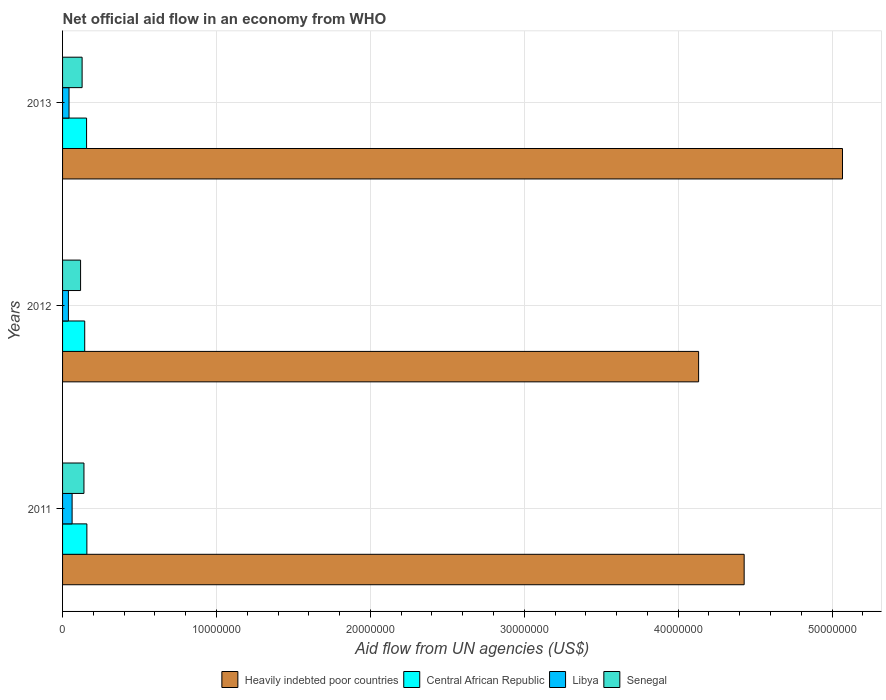How many different coloured bars are there?
Provide a succinct answer. 4. How many groups of bars are there?
Ensure brevity in your answer.  3. Are the number of bars per tick equal to the number of legend labels?
Give a very brief answer. Yes. How many bars are there on the 2nd tick from the top?
Give a very brief answer. 4. What is the net official aid flow in Libya in 2012?
Make the answer very short. 3.80e+05. Across all years, what is the maximum net official aid flow in Libya?
Your answer should be very brief. 6.20e+05. Across all years, what is the minimum net official aid flow in Senegal?
Keep it short and to the point. 1.17e+06. What is the total net official aid flow in Libya in the graph?
Provide a short and direct response. 1.42e+06. What is the difference between the net official aid flow in Heavily indebted poor countries in 2011 and that in 2013?
Provide a succinct answer. -6.39e+06. What is the average net official aid flow in Senegal per year?
Make the answer very short. 1.28e+06. In the year 2012, what is the difference between the net official aid flow in Libya and net official aid flow in Heavily indebted poor countries?
Your answer should be very brief. -4.10e+07. What is the ratio of the net official aid flow in Heavily indebted poor countries in 2012 to that in 2013?
Offer a terse response. 0.82. Is the difference between the net official aid flow in Libya in 2011 and 2012 greater than the difference between the net official aid flow in Heavily indebted poor countries in 2011 and 2012?
Your response must be concise. No. Is the sum of the net official aid flow in Senegal in 2011 and 2013 greater than the maximum net official aid flow in Central African Republic across all years?
Provide a short and direct response. Yes. What does the 2nd bar from the top in 2011 represents?
Offer a terse response. Libya. What does the 2nd bar from the bottom in 2011 represents?
Make the answer very short. Central African Republic. Is it the case that in every year, the sum of the net official aid flow in Heavily indebted poor countries and net official aid flow in Senegal is greater than the net official aid flow in Libya?
Your response must be concise. Yes. Are all the bars in the graph horizontal?
Give a very brief answer. Yes. Are the values on the major ticks of X-axis written in scientific E-notation?
Ensure brevity in your answer.  No. Does the graph contain grids?
Your answer should be very brief. Yes. Where does the legend appear in the graph?
Your answer should be very brief. Bottom center. How many legend labels are there?
Ensure brevity in your answer.  4. What is the title of the graph?
Your response must be concise. Net official aid flow in an economy from WHO. What is the label or title of the X-axis?
Your response must be concise. Aid flow from UN agencies (US$). What is the label or title of the Y-axis?
Provide a short and direct response. Years. What is the Aid flow from UN agencies (US$) in Heavily indebted poor countries in 2011?
Provide a short and direct response. 4.43e+07. What is the Aid flow from UN agencies (US$) in Central African Republic in 2011?
Provide a short and direct response. 1.58e+06. What is the Aid flow from UN agencies (US$) in Libya in 2011?
Make the answer very short. 6.20e+05. What is the Aid flow from UN agencies (US$) of Senegal in 2011?
Keep it short and to the point. 1.39e+06. What is the Aid flow from UN agencies (US$) of Heavily indebted poor countries in 2012?
Offer a terse response. 4.13e+07. What is the Aid flow from UN agencies (US$) in Central African Republic in 2012?
Make the answer very short. 1.44e+06. What is the Aid flow from UN agencies (US$) of Libya in 2012?
Ensure brevity in your answer.  3.80e+05. What is the Aid flow from UN agencies (US$) in Senegal in 2012?
Give a very brief answer. 1.17e+06. What is the Aid flow from UN agencies (US$) in Heavily indebted poor countries in 2013?
Make the answer very short. 5.07e+07. What is the Aid flow from UN agencies (US$) in Central African Republic in 2013?
Keep it short and to the point. 1.56e+06. What is the Aid flow from UN agencies (US$) of Senegal in 2013?
Give a very brief answer. 1.27e+06. Across all years, what is the maximum Aid flow from UN agencies (US$) in Heavily indebted poor countries?
Ensure brevity in your answer.  5.07e+07. Across all years, what is the maximum Aid flow from UN agencies (US$) of Central African Republic?
Keep it short and to the point. 1.58e+06. Across all years, what is the maximum Aid flow from UN agencies (US$) in Libya?
Give a very brief answer. 6.20e+05. Across all years, what is the maximum Aid flow from UN agencies (US$) of Senegal?
Ensure brevity in your answer.  1.39e+06. Across all years, what is the minimum Aid flow from UN agencies (US$) in Heavily indebted poor countries?
Offer a very short reply. 4.13e+07. Across all years, what is the minimum Aid flow from UN agencies (US$) in Central African Republic?
Your response must be concise. 1.44e+06. Across all years, what is the minimum Aid flow from UN agencies (US$) in Senegal?
Your answer should be very brief. 1.17e+06. What is the total Aid flow from UN agencies (US$) in Heavily indebted poor countries in the graph?
Provide a succinct answer. 1.36e+08. What is the total Aid flow from UN agencies (US$) in Central African Republic in the graph?
Keep it short and to the point. 4.58e+06. What is the total Aid flow from UN agencies (US$) of Libya in the graph?
Provide a succinct answer. 1.42e+06. What is the total Aid flow from UN agencies (US$) in Senegal in the graph?
Ensure brevity in your answer.  3.83e+06. What is the difference between the Aid flow from UN agencies (US$) in Heavily indebted poor countries in 2011 and that in 2012?
Offer a terse response. 2.96e+06. What is the difference between the Aid flow from UN agencies (US$) of Central African Republic in 2011 and that in 2012?
Offer a very short reply. 1.40e+05. What is the difference between the Aid flow from UN agencies (US$) in Libya in 2011 and that in 2012?
Your response must be concise. 2.40e+05. What is the difference between the Aid flow from UN agencies (US$) in Heavily indebted poor countries in 2011 and that in 2013?
Make the answer very short. -6.39e+06. What is the difference between the Aid flow from UN agencies (US$) of Central African Republic in 2011 and that in 2013?
Provide a succinct answer. 2.00e+04. What is the difference between the Aid flow from UN agencies (US$) in Senegal in 2011 and that in 2013?
Give a very brief answer. 1.20e+05. What is the difference between the Aid flow from UN agencies (US$) in Heavily indebted poor countries in 2012 and that in 2013?
Make the answer very short. -9.35e+06. What is the difference between the Aid flow from UN agencies (US$) in Central African Republic in 2012 and that in 2013?
Make the answer very short. -1.20e+05. What is the difference between the Aid flow from UN agencies (US$) of Libya in 2012 and that in 2013?
Offer a very short reply. -4.00e+04. What is the difference between the Aid flow from UN agencies (US$) in Heavily indebted poor countries in 2011 and the Aid flow from UN agencies (US$) in Central African Republic in 2012?
Offer a very short reply. 4.28e+07. What is the difference between the Aid flow from UN agencies (US$) in Heavily indebted poor countries in 2011 and the Aid flow from UN agencies (US$) in Libya in 2012?
Your response must be concise. 4.39e+07. What is the difference between the Aid flow from UN agencies (US$) of Heavily indebted poor countries in 2011 and the Aid flow from UN agencies (US$) of Senegal in 2012?
Provide a short and direct response. 4.31e+07. What is the difference between the Aid flow from UN agencies (US$) in Central African Republic in 2011 and the Aid flow from UN agencies (US$) in Libya in 2012?
Make the answer very short. 1.20e+06. What is the difference between the Aid flow from UN agencies (US$) of Libya in 2011 and the Aid flow from UN agencies (US$) of Senegal in 2012?
Your answer should be compact. -5.50e+05. What is the difference between the Aid flow from UN agencies (US$) in Heavily indebted poor countries in 2011 and the Aid flow from UN agencies (US$) in Central African Republic in 2013?
Provide a succinct answer. 4.27e+07. What is the difference between the Aid flow from UN agencies (US$) in Heavily indebted poor countries in 2011 and the Aid flow from UN agencies (US$) in Libya in 2013?
Provide a short and direct response. 4.39e+07. What is the difference between the Aid flow from UN agencies (US$) in Heavily indebted poor countries in 2011 and the Aid flow from UN agencies (US$) in Senegal in 2013?
Your response must be concise. 4.30e+07. What is the difference between the Aid flow from UN agencies (US$) in Central African Republic in 2011 and the Aid flow from UN agencies (US$) in Libya in 2013?
Offer a very short reply. 1.16e+06. What is the difference between the Aid flow from UN agencies (US$) of Libya in 2011 and the Aid flow from UN agencies (US$) of Senegal in 2013?
Make the answer very short. -6.50e+05. What is the difference between the Aid flow from UN agencies (US$) of Heavily indebted poor countries in 2012 and the Aid flow from UN agencies (US$) of Central African Republic in 2013?
Provide a succinct answer. 3.98e+07. What is the difference between the Aid flow from UN agencies (US$) in Heavily indebted poor countries in 2012 and the Aid flow from UN agencies (US$) in Libya in 2013?
Provide a succinct answer. 4.09e+07. What is the difference between the Aid flow from UN agencies (US$) in Heavily indebted poor countries in 2012 and the Aid flow from UN agencies (US$) in Senegal in 2013?
Give a very brief answer. 4.01e+07. What is the difference between the Aid flow from UN agencies (US$) in Central African Republic in 2012 and the Aid flow from UN agencies (US$) in Libya in 2013?
Offer a very short reply. 1.02e+06. What is the difference between the Aid flow from UN agencies (US$) of Central African Republic in 2012 and the Aid flow from UN agencies (US$) of Senegal in 2013?
Provide a succinct answer. 1.70e+05. What is the difference between the Aid flow from UN agencies (US$) of Libya in 2012 and the Aid flow from UN agencies (US$) of Senegal in 2013?
Offer a very short reply. -8.90e+05. What is the average Aid flow from UN agencies (US$) in Heavily indebted poor countries per year?
Provide a succinct answer. 4.54e+07. What is the average Aid flow from UN agencies (US$) in Central African Republic per year?
Offer a very short reply. 1.53e+06. What is the average Aid flow from UN agencies (US$) in Libya per year?
Your answer should be compact. 4.73e+05. What is the average Aid flow from UN agencies (US$) of Senegal per year?
Provide a short and direct response. 1.28e+06. In the year 2011, what is the difference between the Aid flow from UN agencies (US$) in Heavily indebted poor countries and Aid flow from UN agencies (US$) in Central African Republic?
Your answer should be very brief. 4.27e+07. In the year 2011, what is the difference between the Aid flow from UN agencies (US$) of Heavily indebted poor countries and Aid flow from UN agencies (US$) of Libya?
Keep it short and to the point. 4.37e+07. In the year 2011, what is the difference between the Aid flow from UN agencies (US$) of Heavily indebted poor countries and Aid flow from UN agencies (US$) of Senegal?
Ensure brevity in your answer.  4.29e+07. In the year 2011, what is the difference between the Aid flow from UN agencies (US$) of Central African Republic and Aid flow from UN agencies (US$) of Libya?
Give a very brief answer. 9.60e+05. In the year 2011, what is the difference between the Aid flow from UN agencies (US$) in Libya and Aid flow from UN agencies (US$) in Senegal?
Provide a short and direct response. -7.70e+05. In the year 2012, what is the difference between the Aid flow from UN agencies (US$) in Heavily indebted poor countries and Aid flow from UN agencies (US$) in Central African Republic?
Give a very brief answer. 3.99e+07. In the year 2012, what is the difference between the Aid flow from UN agencies (US$) of Heavily indebted poor countries and Aid flow from UN agencies (US$) of Libya?
Give a very brief answer. 4.10e+07. In the year 2012, what is the difference between the Aid flow from UN agencies (US$) in Heavily indebted poor countries and Aid flow from UN agencies (US$) in Senegal?
Your response must be concise. 4.02e+07. In the year 2012, what is the difference between the Aid flow from UN agencies (US$) of Central African Republic and Aid flow from UN agencies (US$) of Libya?
Provide a short and direct response. 1.06e+06. In the year 2012, what is the difference between the Aid flow from UN agencies (US$) of Libya and Aid flow from UN agencies (US$) of Senegal?
Make the answer very short. -7.90e+05. In the year 2013, what is the difference between the Aid flow from UN agencies (US$) in Heavily indebted poor countries and Aid flow from UN agencies (US$) in Central African Republic?
Your response must be concise. 4.91e+07. In the year 2013, what is the difference between the Aid flow from UN agencies (US$) of Heavily indebted poor countries and Aid flow from UN agencies (US$) of Libya?
Give a very brief answer. 5.03e+07. In the year 2013, what is the difference between the Aid flow from UN agencies (US$) of Heavily indebted poor countries and Aid flow from UN agencies (US$) of Senegal?
Keep it short and to the point. 4.94e+07. In the year 2013, what is the difference between the Aid flow from UN agencies (US$) in Central African Republic and Aid flow from UN agencies (US$) in Libya?
Make the answer very short. 1.14e+06. In the year 2013, what is the difference between the Aid flow from UN agencies (US$) in Libya and Aid flow from UN agencies (US$) in Senegal?
Keep it short and to the point. -8.50e+05. What is the ratio of the Aid flow from UN agencies (US$) in Heavily indebted poor countries in 2011 to that in 2012?
Give a very brief answer. 1.07. What is the ratio of the Aid flow from UN agencies (US$) in Central African Republic in 2011 to that in 2012?
Keep it short and to the point. 1.1. What is the ratio of the Aid flow from UN agencies (US$) of Libya in 2011 to that in 2012?
Offer a very short reply. 1.63. What is the ratio of the Aid flow from UN agencies (US$) of Senegal in 2011 to that in 2012?
Offer a terse response. 1.19. What is the ratio of the Aid flow from UN agencies (US$) of Heavily indebted poor countries in 2011 to that in 2013?
Provide a succinct answer. 0.87. What is the ratio of the Aid flow from UN agencies (US$) in Central African Republic in 2011 to that in 2013?
Ensure brevity in your answer.  1.01. What is the ratio of the Aid flow from UN agencies (US$) in Libya in 2011 to that in 2013?
Give a very brief answer. 1.48. What is the ratio of the Aid flow from UN agencies (US$) of Senegal in 2011 to that in 2013?
Your answer should be very brief. 1.09. What is the ratio of the Aid flow from UN agencies (US$) in Heavily indebted poor countries in 2012 to that in 2013?
Make the answer very short. 0.82. What is the ratio of the Aid flow from UN agencies (US$) in Central African Republic in 2012 to that in 2013?
Offer a terse response. 0.92. What is the ratio of the Aid flow from UN agencies (US$) in Libya in 2012 to that in 2013?
Your answer should be compact. 0.9. What is the ratio of the Aid flow from UN agencies (US$) in Senegal in 2012 to that in 2013?
Ensure brevity in your answer.  0.92. What is the difference between the highest and the second highest Aid flow from UN agencies (US$) of Heavily indebted poor countries?
Your answer should be very brief. 6.39e+06. What is the difference between the highest and the second highest Aid flow from UN agencies (US$) of Central African Republic?
Give a very brief answer. 2.00e+04. What is the difference between the highest and the second highest Aid flow from UN agencies (US$) of Libya?
Your answer should be very brief. 2.00e+05. What is the difference between the highest and the second highest Aid flow from UN agencies (US$) in Senegal?
Ensure brevity in your answer.  1.20e+05. What is the difference between the highest and the lowest Aid flow from UN agencies (US$) of Heavily indebted poor countries?
Your answer should be compact. 9.35e+06. What is the difference between the highest and the lowest Aid flow from UN agencies (US$) of Central African Republic?
Offer a very short reply. 1.40e+05. What is the difference between the highest and the lowest Aid flow from UN agencies (US$) of Senegal?
Offer a terse response. 2.20e+05. 